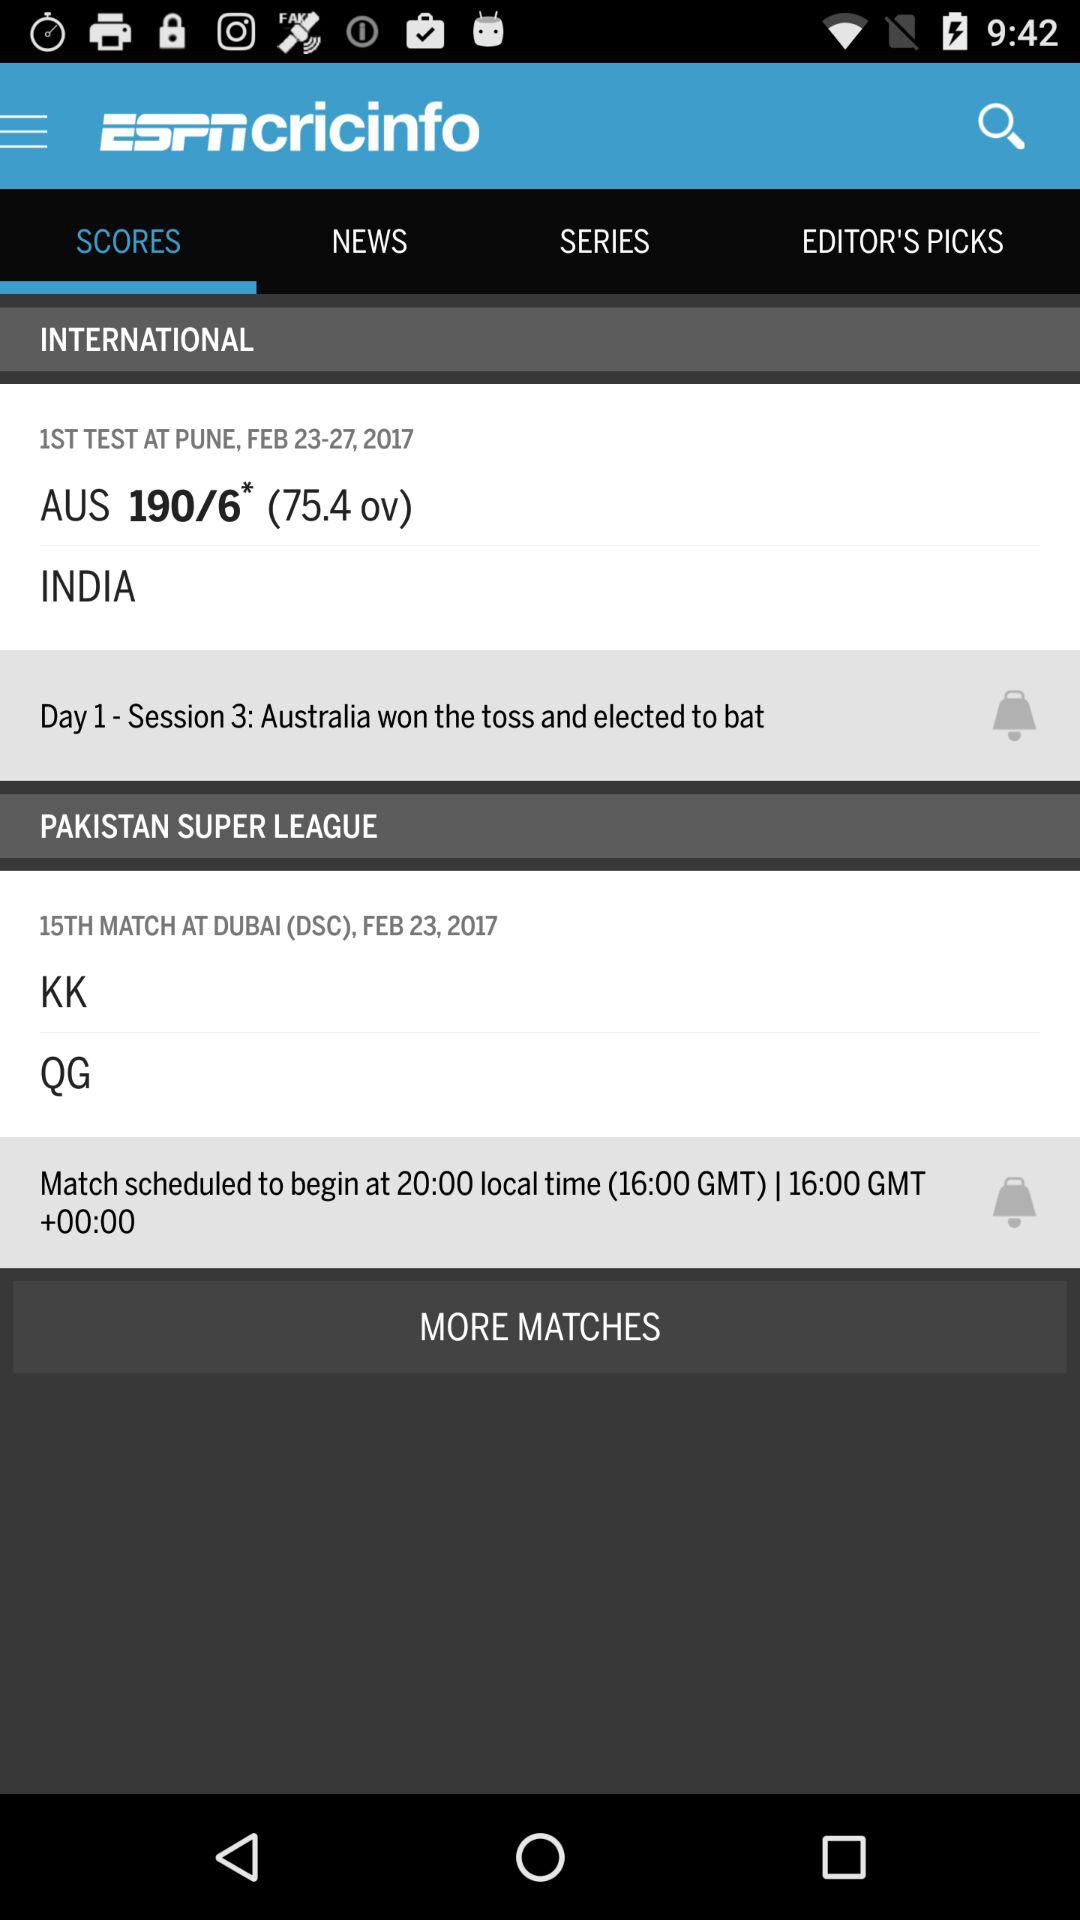How many wickets fell for "Australia"? The number of wickets that fell for "Australia" is 6. 